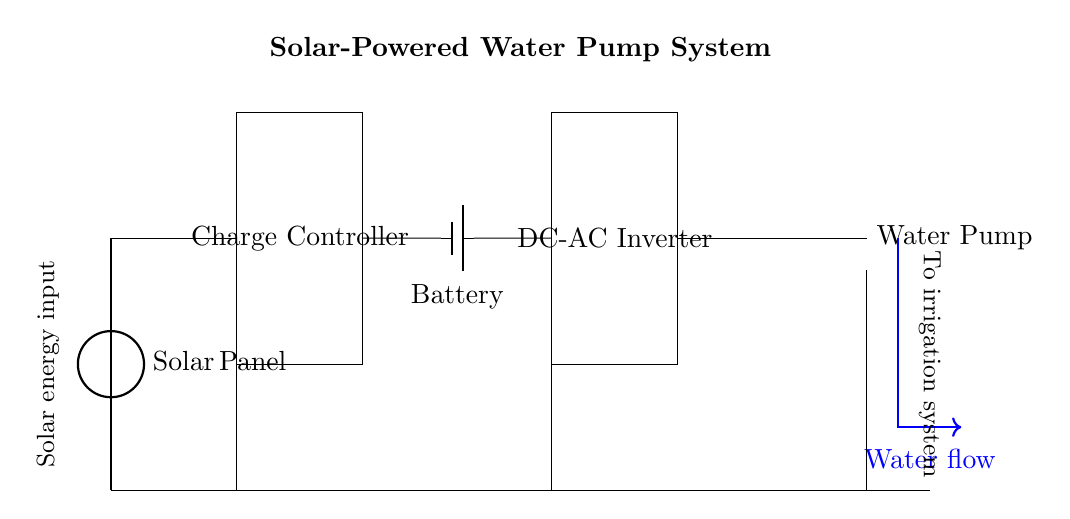What component converts solar energy into electrical energy? The solar panel is the component in the circuit that collects solar energy and converts it into electrical energy.
Answer: Solar Panel What is the purpose of the charge controller in this circuit? The charge controller manages the flow of electrical energy from the solar panel to the battery, ensuring that the battery is charged properly and preventing overcharging.
Answer: Battery charging protection What type of motor is used in the system? The circuit features an AC motor, which helps in converting electrical energy into mechanical energy to pump water.
Answer: AC Motor How many main components are there in this circuit? The circuit consists of four main components: the solar panel, charge controller, battery, and DC-AC inverter.
Answer: Four What is the direction of water flow indicated in the diagram? The water flow is represented by a blue arrow pointing downward, indicating the direction of water from the pump to the irrigation system.
Answer: Downward Why is a DC-AC inverter included in this circuit? The DC-AC inverter converts the direct current from the battery into alternating current to power the AC motor used for the water pump, which operates on AC power.
Answer: To convert DC to AC 